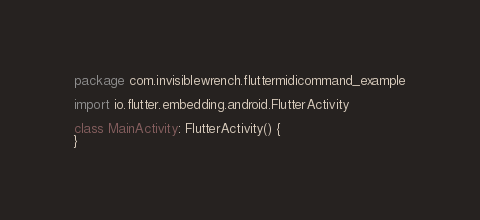<code> <loc_0><loc_0><loc_500><loc_500><_Kotlin_>package com.invisiblewrench.fluttermidicommand_example

import io.flutter.embedding.android.FlutterActivity

class MainActivity: FlutterActivity() {
}
</code> 